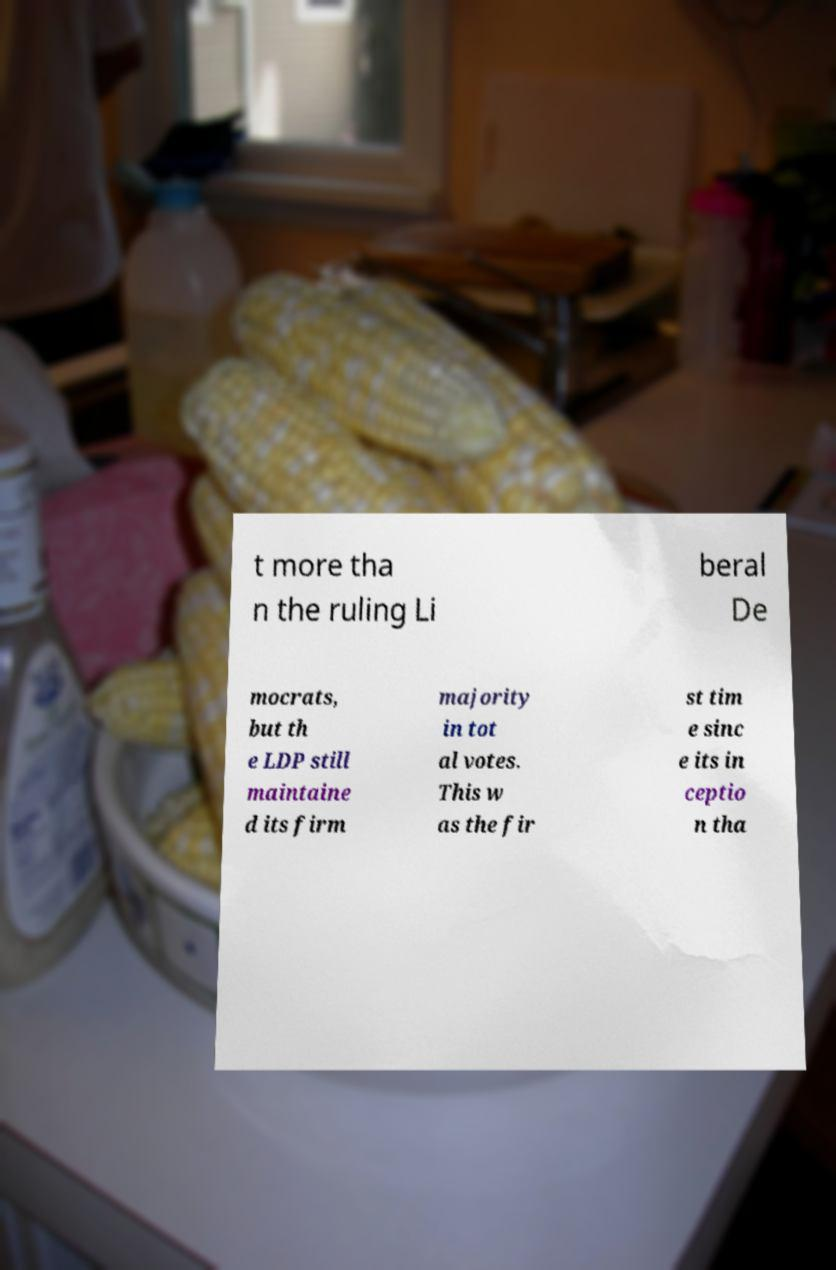Please identify and transcribe the text found in this image. t more tha n the ruling Li beral De mocrats, but th e LDP still maintaine d its firm majority in tot al votes. This w as the fir st tim e sinc e its in ceptio n tha 